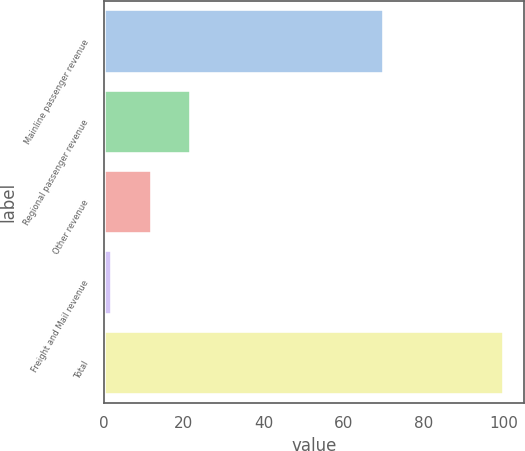<chart> <loc_0><loc_0><loc_500><loc_500><bar_chart><fcel>Mainline passenger revenue<fcel>Regional passenger revenue<fcel>Other revenue<fcel>Freight and Mail revenue<fcel>Total<nl><fcel>70<fcel>21.8<fcel>12<fcel>2<fcel>100<nl></chart> 